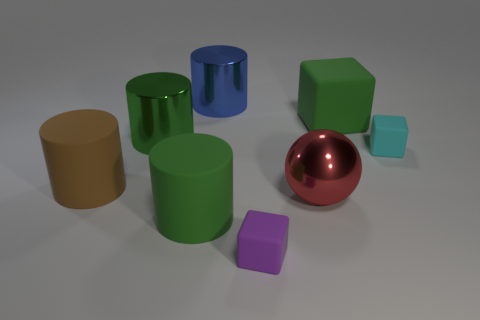Subtract all large blue metallic cylinders. How many cylinders are left? 3 Subtract all brown cylinders. How many cylinders are left? 3 Subtract all cubes. How many objects are left? 5 Add 1 purple things. How many objects exist? 9 Subtract 0 yellow cylinders. How many objects are left? 8 Subtract 4 cylinders. How many cylinders are left? 0 Subtract all purple spheres. Subtract all blue cylinders. How many spheres are left? 1 Subtract all green cubes. How many brown cylinders are left? 1 Subtract all large gray metal spheres. Subtract all big green rubber blocks. How many objects are left? 7 Add 7 tiny things. How many tiny things are left? 9 